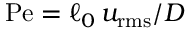<formula> <loc_0><loc_0><loc_500><loc_500>P e = \ell _ { 0 } \, u _ { r m s } / D</formula> 